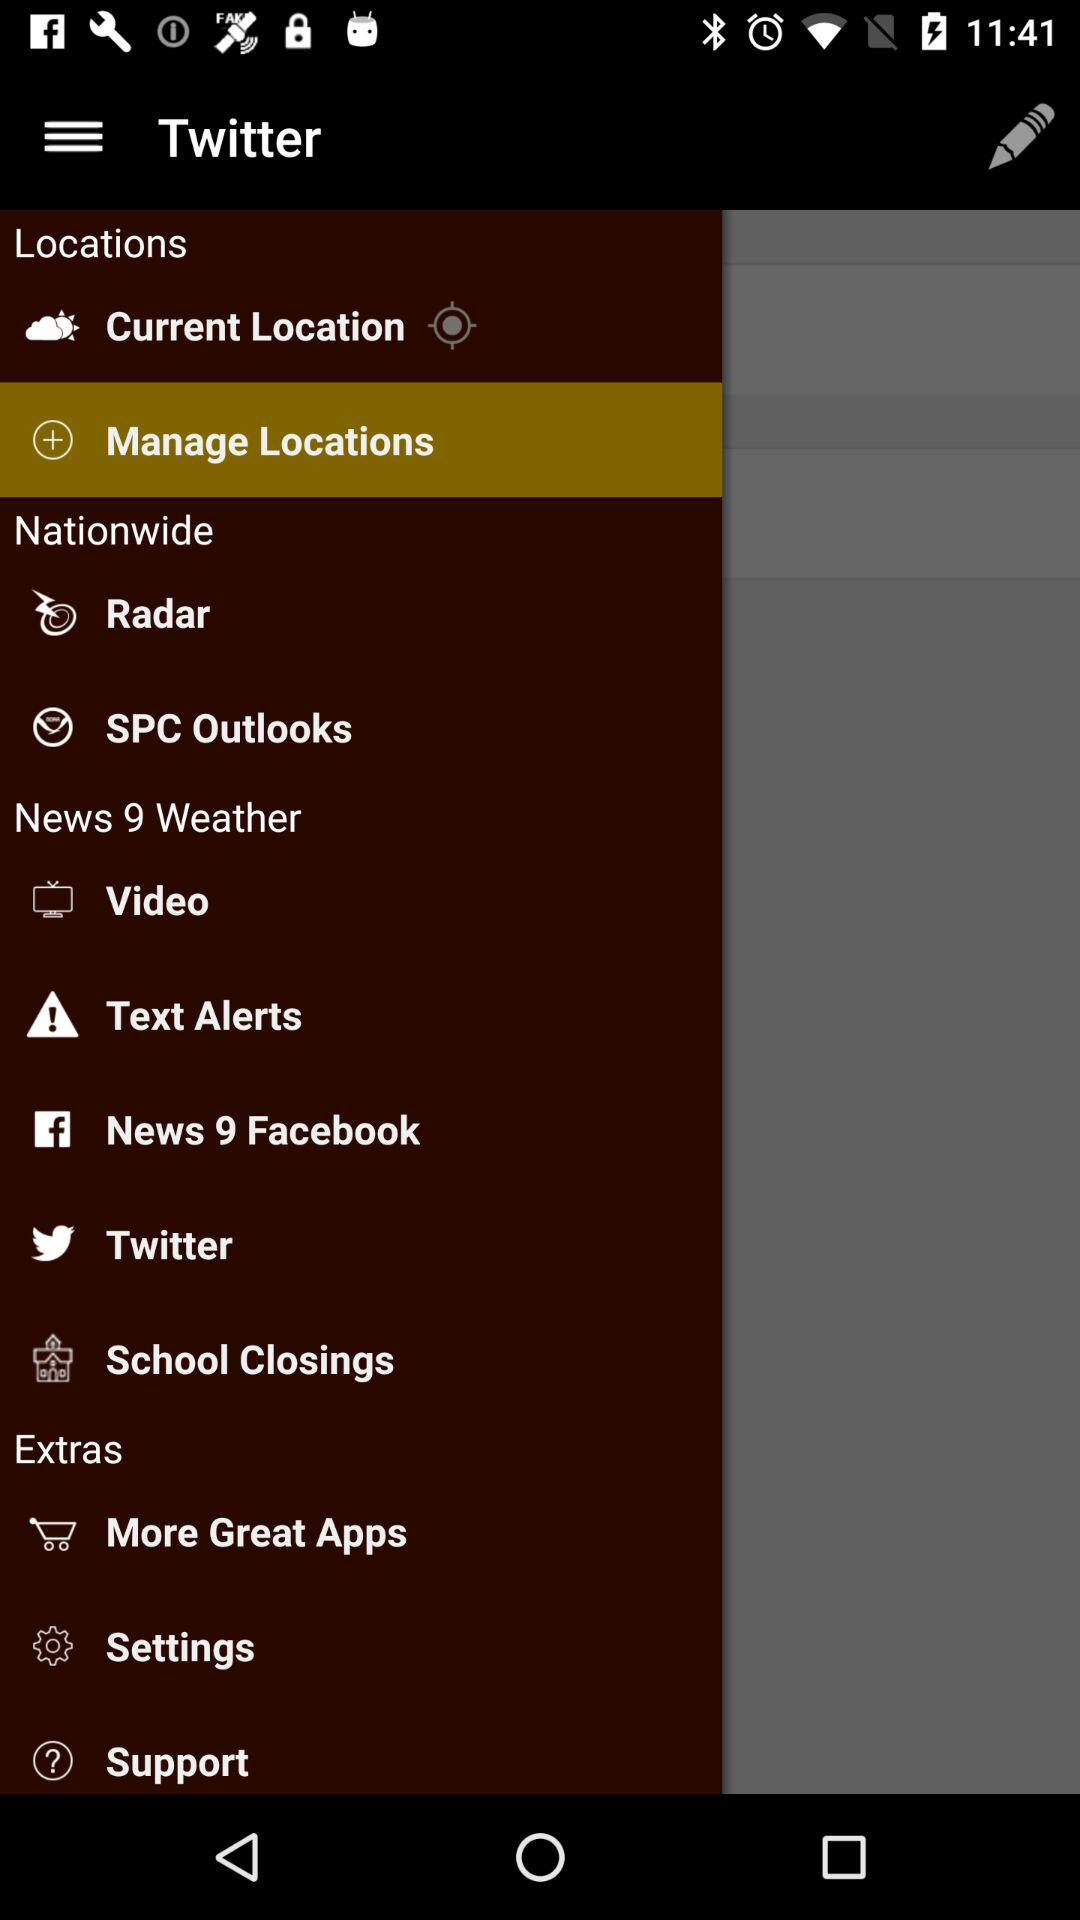What is the application name? The application name is "Twitter". 